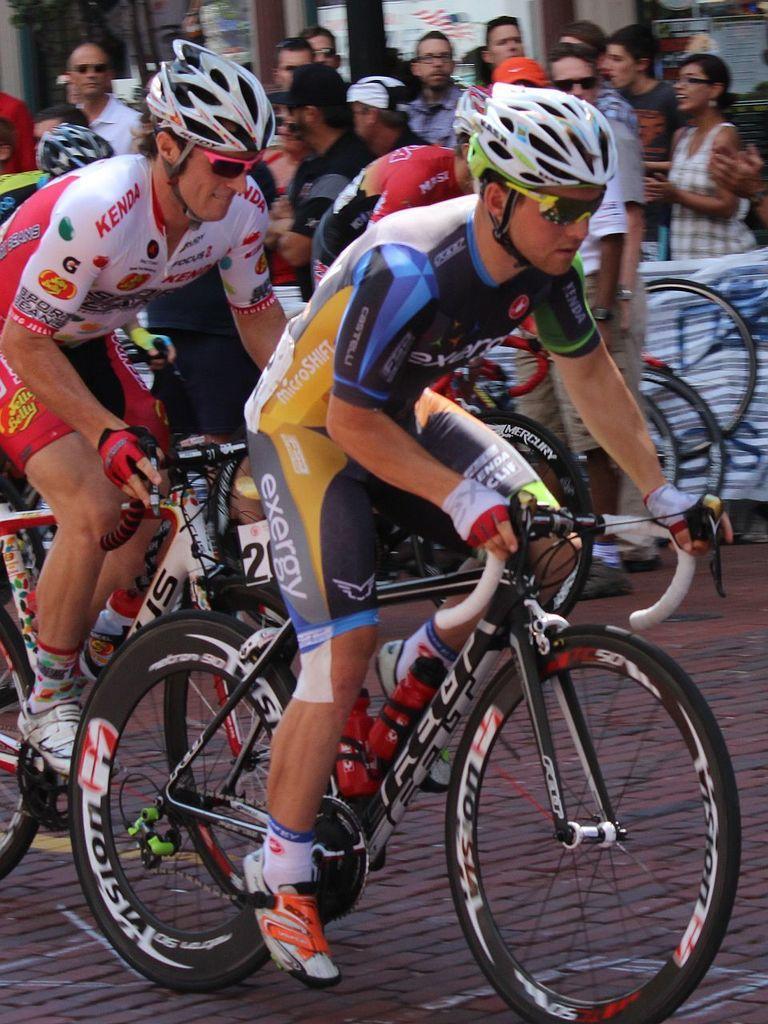Please provide a concise description of this image. In this image I see number of people in which few of them are on cycles and rest of them are on the path. 